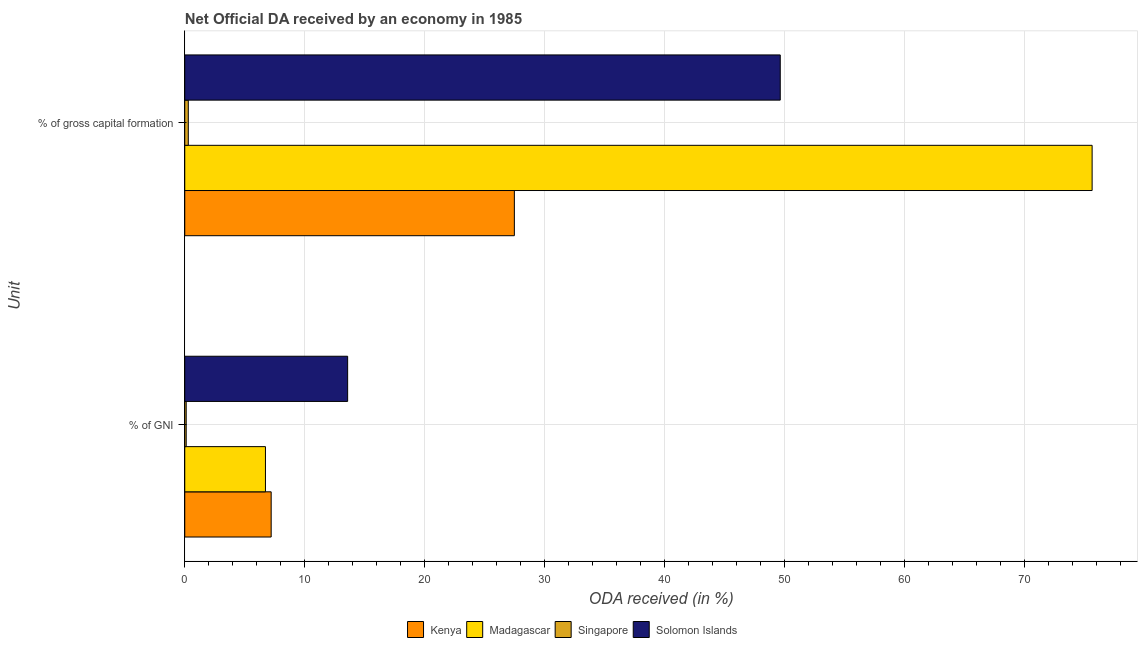How many different coloured bars are there?
Ensure brevity in your answer.  4. How many groups of bars are there?
Make the answer very short. 2. Are the number of bars per tick equal to the number of legend labels?
Offer a very short reply. Yes. Are the number of bars on each tick of the Y-axis equal?
Your response must be concise. Yes. How many bars are there on the 1st tick from the bottom?
Keep it short and to the point. 4. What is the label of the 1st group of bars from the top?
Provide a succinct answer. % of gross capital formation. What is the oda received as percentage of gross capital formation in Kenya?
Make the answer very short. 27.46. Across all countries, what is the maximum oda received as percentage of gross capital formation?
Your answer should be very brief. 75.6. Across all countries, what is the minimum oda received as percentage of gross capital formation?
Offer a very short reply. 0.3. In which country was the oda received as percentage of gni maximum?
Keep it short and to the point. Solomon Islands. In which country was the oda received as percentage of gross capital formation minimum?
Offer a very short reply. Singapore. What is the total oda received as percentage of gni in the graph?
Ensure brevity in your answer.  27.62. What is the difference between the oda received as percentage of gni in Singapore and that in Madagascar?
Ensure brevity in your answer.  -6.6. What is the difference between the oda received as percentage of gross capital formation in Madagascar and the oda received as percentage of gni in Singapore?
Your answer should be compact. 75.48. What is the average oda received as percentage of gross capital formation per country?
Give a very brief answer. 38.24. What is the difference between the oda received as percentage of gni and oda received as percentage of gross capital formation in Madagascar?
Provide a short and direct response. -68.87. What is the ratio of the oda received as percentage of gross capital formation in Singapore to that in Kenya?
Offer a very short reply. 0.01. In how many countries, is the oda received as percentage of gross capital formation greater than the average oda received as percentage of gross capital formation taken over all countries?
Provide a short and direct response. 2. What does the 2nd bar from the top in % of GNI represents?
Offer a very short reply. Singapore. What does the 3rd bar from the bottom in % of gross capital formation represents?
Provide a short and direct response. Singapore. How many bars are there?
Ensure brevity in your answer.  8. Where does the legend appear in the graph?
Offer a terse response. Bottom center. How many legend labels are there?
Make the answer very short. 4. What is the title of the graph?
Provide a short and direct response. Net Official DA received by an economy in 1985. What is the label or title of the X-axis?
Make the answer very short. ODA received (in %). What is the label or title of the Y-axis?
Offer a very short reply. Unit. What is the ODA received (in %) of Kenya in % of GNI?
Ensure brevity in your answer.  7.2. What is the ODA received (in %) of Madagascar in % of GNI?
Provide a short and direct response. 6.72. What is the ODA received (in %) in Singapore in % of GNI?
Provide a succinct answer. 0.12. What is the ODA received (in %) of Solomon Islands in % of GNI?
Provide a succinct answer. 13.57. What is the ODA received (in %) of Kenya in % of gross capital formation?
Your answer should be very brief. 27.46. What is the ODA received (in %) of Madagascar in % of gross capital formation?
Your response must be concise. 75.6. What is the ODA received (in %) of Singapore in % of gross capital formation?
Offer a very short reply. 0.3. What is the ODA received (in %) in Solomon Islands in % of gross capital formation?
Ensure brevity in your answer.  49.61. Across all Unit, what is the maximum ODA received (in %) of Kenya?
Provide a succinct answer. 27.46. Across all Unit, what is the maximum ODA received (in %) in Madagascar?
Keep it short and to the point. 75.6. Across all Unit, what is the maximum ODA received (in %) in Singapore?
Provide a succinct answer. 0.3. Across all Unit, what is the maximum ODA received (in %) in Solomon Islands?
Your response must be concise. 49.61. Across all Unit, what is the minimum ODA received (in %) of Kenya?
Your answer should be very brief. 7.2. Across all Unit, what is the minimum ODA received (in %) in Madagascar?
Ensure brevity in your answer.  6.72. Across all Unit, what is the minimum ODA received (in %) in Singapore?
Give a very brief answer. 0.12. Across all Unit, what is the minimum ODA received (in %) in Solomon Islands?
Your answer should be compact. 13.57. What is the total ODA received (in %) of Kenya in the graph?
Your response must be concise. 34.66. What is the total ODA received (in %) in Madagascar in the graph?
Your answer should be compact. 82.32. What is the total ODA received (in %) in Singapore in the graph?
Offer a terse response. 0.42. What is the total ODA received (in %) of Solomon Islands in the graph?
Offer a very short reply. 63.18. What is the difference between the ODA received (in %) in Kenya in % of GNI and that in % of gross capital formation?
Keep it short and to the point. -20.26. What is the difference between the ODA received (in %) of Madagascar in % of GNI and that in % of gross capital formation?
Offer a terse response. -68.87. What is the difference between the ODA received (in %) of Singapore in % of GNI and that in % of gross capital formation?
Keep it short and to the point. -0.17. What is the difference between the ODA received (in %) in Solomon Islands in % of GNI and that in % of gross capital formation?
Make the answer very short. -36.04. What is the difference between the ODA received (in %) of Kenya in % of GNI and the ODA received (in %) of Madagascar in % of gross capital formation?
Make the answer very short. -68.4. What is the difference between the ODA received (in %) of Kenya in % of GNI and the ODA received (in %) of Singapore in % of gross capital formation?
Your response must be concise. 6.9. What is the difference between the ODA received (in %) in Kenya in % of GNI and the ODA received (in %) in Solomon Islands in % of gross capital formation?
Your answer should be very brief. -42.41. What is the difference between the ODA received (in %) of Madagascar in % of GNI and the ODA received (in %) of Singapore in % of gross capital formation?
Keep it short and to the point. 6.43. What is the difference between the ODA received (in %) of Madagascar in % of GNI and the ODA received (in %) of Solomon Islands in % of gross capital formation?
Your answer should be compact. -42.89. What is the difference between the ODA received (in %) in Singapore in % of GNI and the ODA received (in %) in Solomon Islands in % of gross capital formation?
Your answer should be compact. -49.49. What is the average ODA received (in %) in Kenya per Unit?
Offer a very short reply. 17.33. What is the average ODA received (in %) in Madagascar per Unit?
Offer a terse response. 41.16. What is the average ODA received (in %) in Singapore per Unit?
Ensure brevity in your answer.  0.21. What is the average ODA received (in %) of Solomon Islands per Unit?
Offer a very short reply. 31.59. What is the difference between the ODA received (in %) in Kenya and ODA received (in %) in Madagascar in % of GNI?
Keep it short and to the point. 0.48. What is the difference between the ODA received (in %) of Kenya and ODA received (in %) of Singapore in % of GNI?
Keep it short and to the point. 7.08. What is the difference between the ODA received (in %) of Kenya and ODA received (in %) of Solomon Islands in % of GNI?
Provide a short and direct response. -6.37. What is the difference between the ODA received (in %) in Madagascar and ODA received (in %) in Singapore in % of GNI?
Give a very brief answer. 6.6. What is the difference between the ODA received (in %) in Madagascar and ODA received (in %) in Solomon Islands in % of GNI?
Your answer should be very brief. -6.85. What is the difference between the ODA received (in %) in Singapore and ODA received (in %) in Solomon Islands in % of GNI?
Offer a very short reply. -13.45. What is the difference between the ODA received (in %) of Kenya and ODA received (in %) of Madagascar in % of gross capital formation?
Make the answer very short. -48.14. What is the difference between the ODA received (in %) in Kenya and ODA received (in %) in Singapore in % of gross capital formation?
Keep it short and to the point. 27.17. What is the difference between the ODA received (in %) of Kenya and ODA received (in %) of Solomon Islands in % of gross capital formation?
Ensure brevity in your answer.  -22.15. What is the difference between the ODA received (in %) of Madagascar and ODA received (in %) of Singapore in % of gross capital formation?
Your response must be concise. 75.3. What is the difference between the ODA received (in %) in Madagascar and ODA received (in %) in Solomon Islands in % of gross capital formation?
Provide a succinct answer. 25.98. What is the difference between the ODA received (in %) of Singapore and ODA received (in %) of Solomon Islands in % of gross capital formation?
Offer a very short reply. -49.32. What is the ratio of the ODA received (in %) of Kenya in % of GNI to that in % of gross capital formation?
Give a very brief answer. 0.26. What is the ratio of the ODA received (in %) of Madagascar in % of GNI to that in % of gross capital formation?
Provide a short and direct response. 0.09. What is the ratio of the ODA received (in %) in Singapore in % of GNI to that in % of gross capital formation?
Offer a very short reply. 0.41. What is the ratio of the ODA received (in %) of Solomon Islands in % of GNI to that in % of gross capital formation?
Your answer should be very brief. 0.27. What is the difference between the highest and the second highest ODA received (in %) in Kenya?
Your response must be concise. 20.26. What is the difference between the highest and the second highest ODA received (in %) in Madagascar?
Your answer should be compact. 68.87. What is the difference between the highest and the second highest ODA received (in %) in Singapore?
Keep it short and to the point. 0.17. What is the difference between the highest and the second highest ODA received (in %) in Solomon Islands?
Make the answer very short. 36.04. What is the difference between the highest and the lowest ODA received (in %) in Kenya?
Your answer should be very brief. 20.26. What is the difference between the highest and the lowest ODA received (in %) in Madagascar?
Your response must be concise. 68.87. What is the difference between the highest and the lowest ODA received (in %) of Singapore?
Your response must be concise. 0.17. What is the difference between the highest and the lowest ODA received (in %) of Solomon Islands?
Keep it short and to the point. 36.04. 